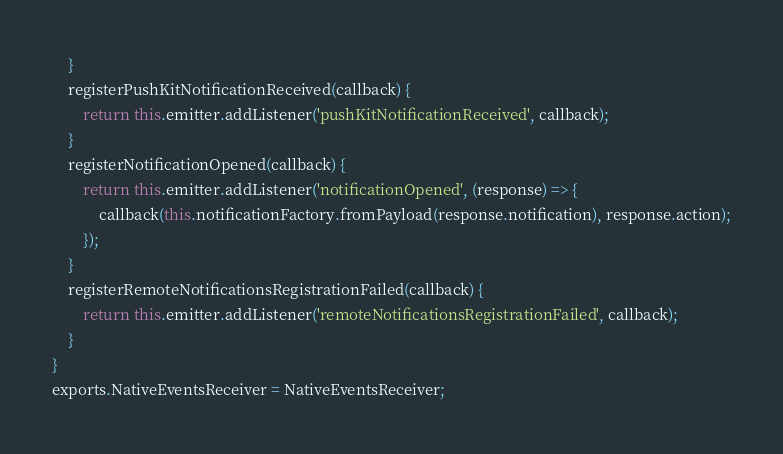Convert code to text. <code><loc_0><loc_0><loc_500><loc_500><_JavaScript_>    }
    registerPushKitNotificationReceived(callback) {
        return this.emitter.addListener('pushKitNotificationReceived', callback);
    }
    registerNotificationOpened(callback) {
        return this.emitter.addListener('notificationOpened', (response) => {
            callback(this.notificationFactory.fromPayload(response.notification), response.action);
        });
    }
    registerRemoteNotificationsRegistrationFailed(callback) {
        return this.emitter.addListener('remoteNotificationsRegistrationFailed', callback);
    }
}
exports.NativeEventsReceiver = NativeEventsReceiver;
</code> 